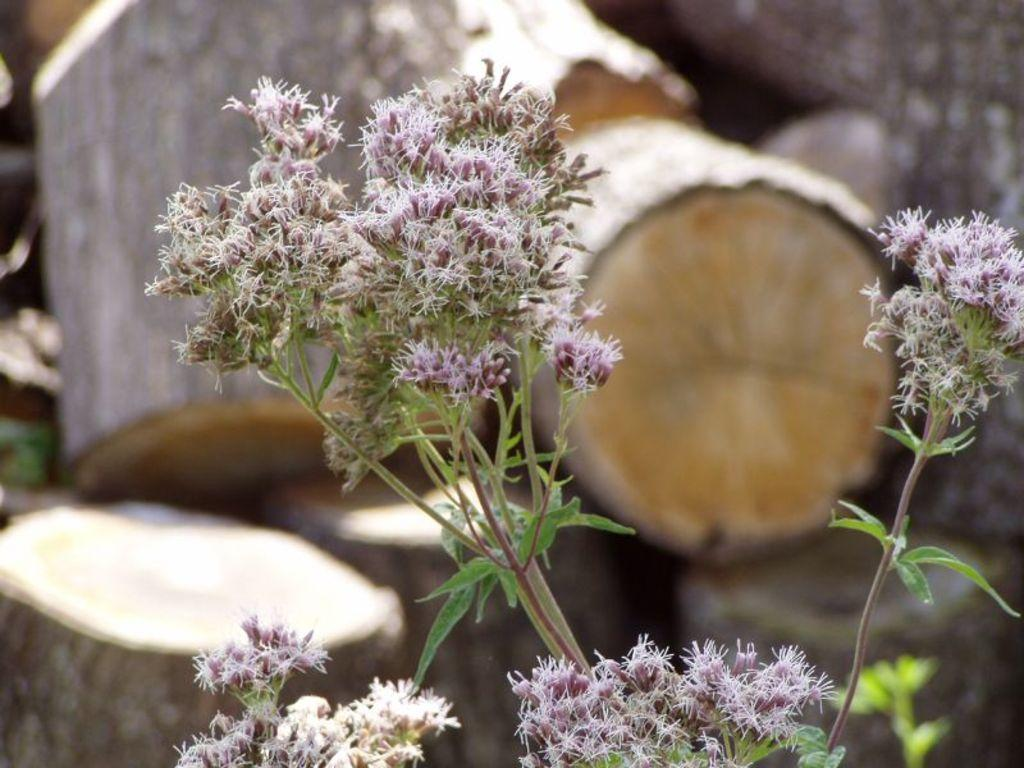What type of living organisms can be seen in the image? Plants can be seen in the image. Where are the plants located in relation to the image? The plants are in the foreground of the image. What other object can be seen in the background of the image? There is a log of wood in the background of the image. How would you describe the appearance of the log of wood? The log of wood appears blurred in the image. What type of rice is being served in the middle of the image? There is no rice present in the image; it features plants in the foreground and a blurred log of wood in the background. 